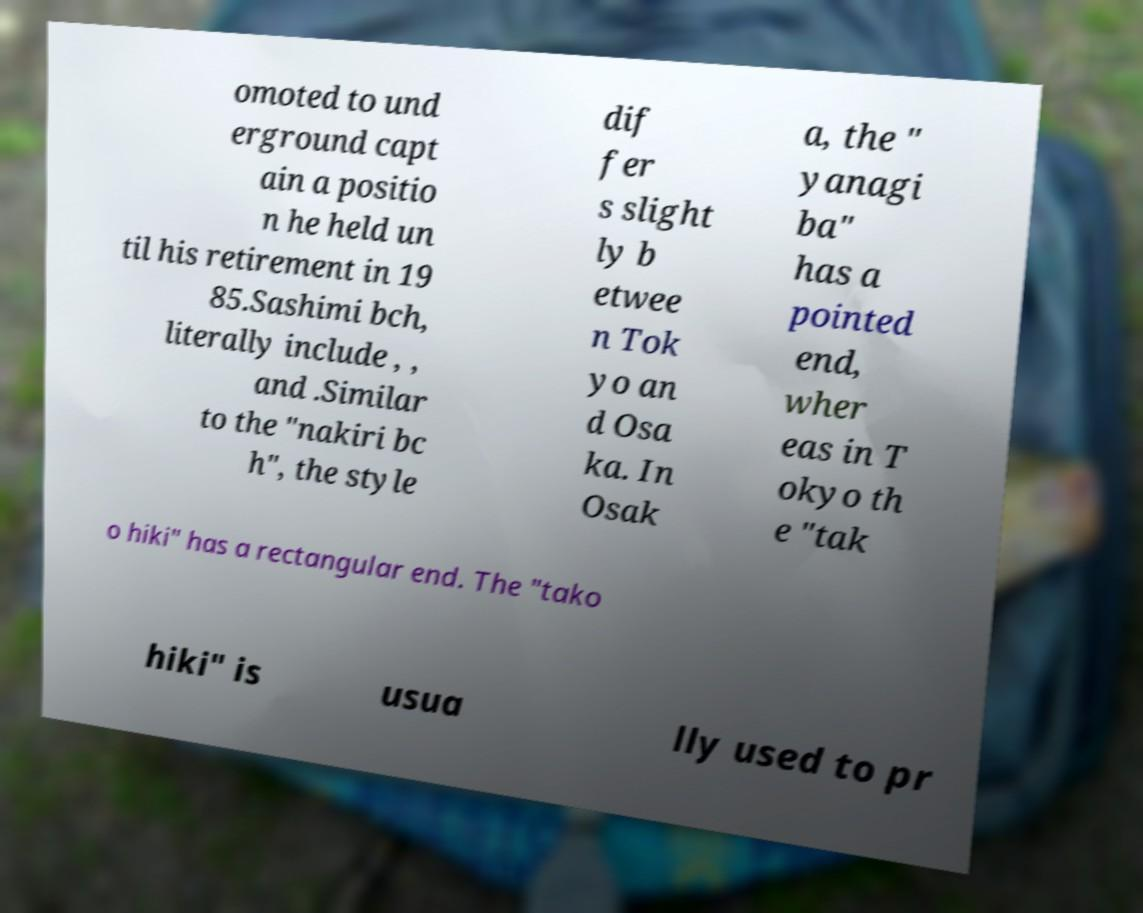I need the written content from this picture converted into text. Can you do that? omoted to und erground capt ain a positio n he held un til his retirement in 19 85.Sashimi bch, literally include , , and .Similar to the "nakiri bc h", the style dif fer s slight ly b etwee n Tok yo an d Osa ka. In Osak a, the " yanagi ba" has a pointed end, wher eas in T okyo th e "tak o hiki" has a rectangular end. The "tako hiki" is usua lly used to pr 